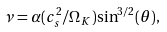<formula> <loc_0><loc_0><loc_500><loc_500>\nu = \alpha ( c _ { s } ^ { 2 } / \Omega _ { K } ) { \sin } ^ { 3 / 2 } ( \theta ) ,</formula> 